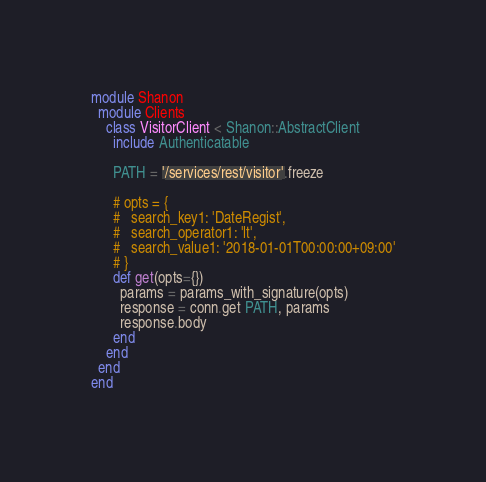<code> <loc_0><loc_0><loc_500><loc_500><_Ruby_>module Shanon
  module Clients
    class VisitorClient < Shanon::AbstractClient
      include Authenticatable

      PATH = '/services/rest/visitor'.freeze

      # opts = {
      #   search_key1: 'DateRegist',
      #   search_operator1: 'lt',
      #   search_value1: '2018-01-01T00:00:00+09:00'
      # }
      def get(opts={})
        params = params_with_signature(opts)
        response = conn.get PATH, params
        response.body
      end
    end
  end
end
</code> 